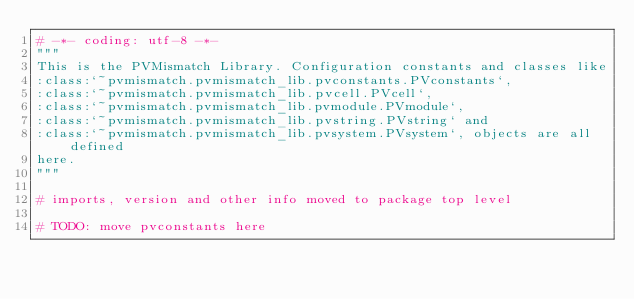<code> <loc_0><loc_0><loc_500><loc_500><_Python_># -*- coding: utf-8 -*-
"""
This is the PVMismatch Library. Configuration constants and classes like
:class:`~pvmismatch.pvmismatch_lib.pvconstants.PVconstants`,
:class:`~pvmismatch.pvmismatch_lib.pvcell.PVcell`,
:class:`~pvmismatch.pvmismatch_lib.pvmodule.PVmodule`,
:class:`~pvmismatch.pvmismatch_lib.pvstring.PVstring` and
:class:`~pvmismatch.pvmismatch_lib.pvsystem.PVsystem`, objects are all defined
here.
"""

# imports, version and other info moved to package top level

# TODO: move pvconstants here
</code> 